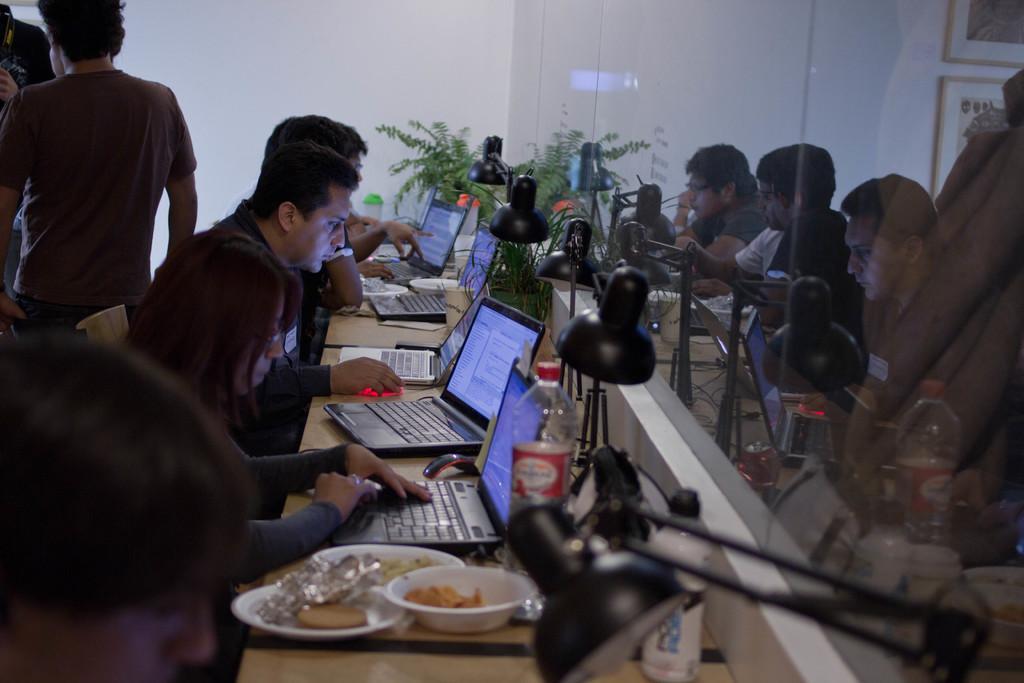Describe this image in one or two sentences. On the left side there are few people sitting on the chairs and looking into the laptops which are placed on a table. Along with the laptops there are few bowls, lamps, food items, bottles and some other objects are placed. In the background few people are standing. On the right side there is a glass on which I can see the reflection of these people. In the background there is a wall and also there is a plant. 